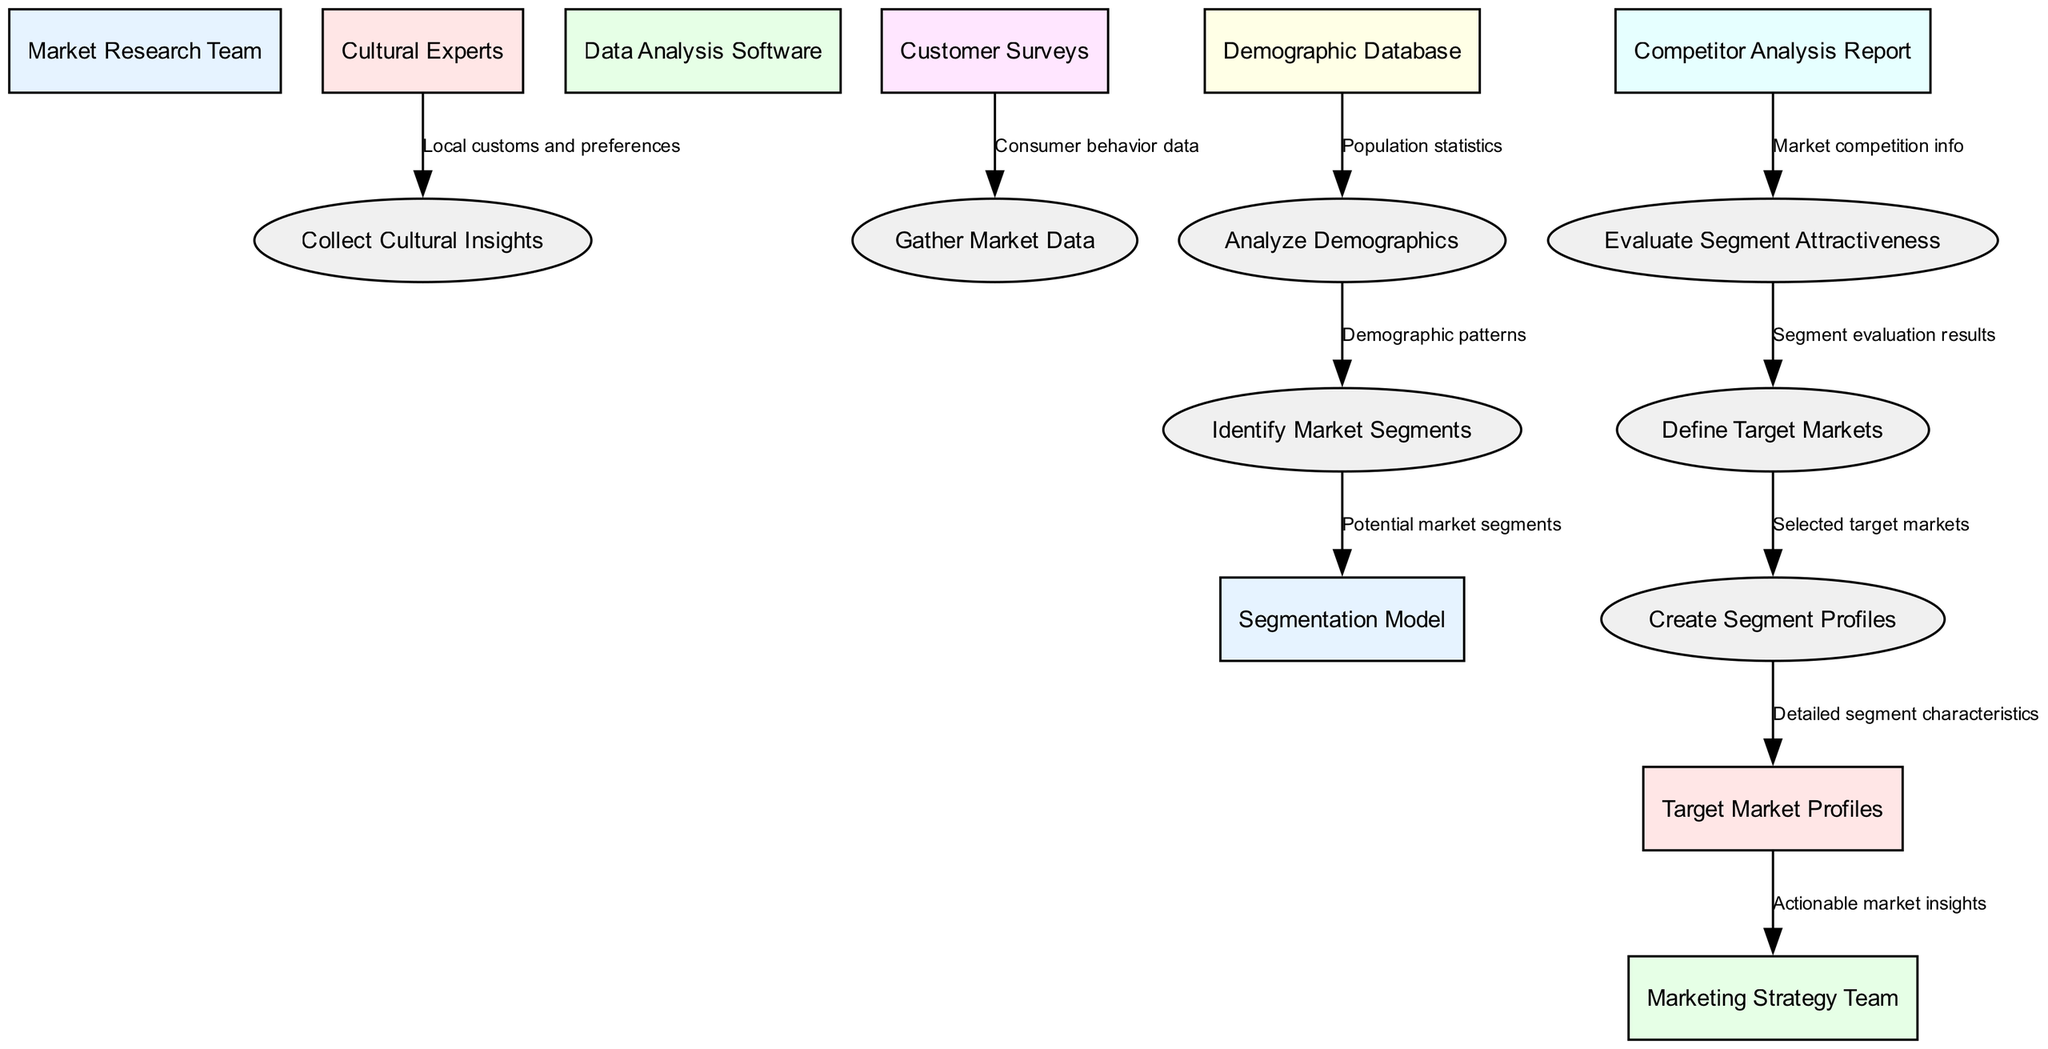What are the two main categories in the diagram? The diagram contains two main categories: entities and processes. The entities include the Market Research Team, Cultural Experts, Data Analysis Software, and others, while the processes include Collect Cultural Insights, Gather Market Data, Analyze Demographics, and others.
Answer: entities and processes How many processes are represented in the diagram? The diagram shows a total of seven processes, which are Collect Cultural Insights, Gather Market Data, Analyze Demographics, Identify Market Segments, Evaluate Segment Attractiveness, Define Target Markets, and Create Segment Profiles.
Answer: seven What is the data source for "Analyze Demographics"? The data source for "Analyze Demographics" is the Demographic Database, which provides population statistics used in the analysis.
Answer: Demographic Database Which node receives actionable market insights? The node that receives actionable market insights is the Marketing Strategy Team, which is directly connected to the Target Market Profiles.
Answer: Marketing Strategy Team What label connects "Define Target Markets" to "Create Segment Profiles"? The label connecting "Define Target Markets" to "Create Segment Profiles" is "Selected target markets", which indicates the selected markets to create detailed profiles.
Answer: Selected target markets Which process follows "Gather Market Data"? The process that follows "Gather Market Data" is "Analyze Demographics", which uses the data gathered from customer surveys for demographic analysis.
Answer: Analyze Demographics How does "Evaluate Segment Attractiveness" receive information? "Evaluate Segment Attractiveness" receives information from the Competitor Analysis Report, which supplies market competition information for the evaluation process.
Answer: Competitor Analysis Report What type of data flows from "Cultural Experts" to "Collect Cultural Insights"? The type of data that flows from "Cultural Experts" to "Collect Cultural Insights" is labeled "Local customs and preferences", highlighting the cultural aspects being collected.
Answer: Local customs and preferences Which two processes directly connect to "Create Segment Profiles"? The two processes that directly connect to "Create Segment Profiles" are "Define Target Markets" and "Target Market Profiles", indicating the workflow from defining markets to creating profiles.
Answer: Define Target Markets and Target Market Profiles 